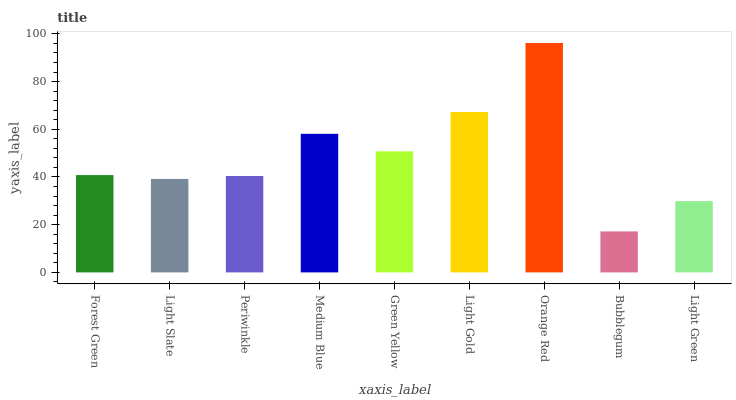Is Bubblegum the minimum?
Answer yes or no. Yes. Is Orange Red the maximum?
Answer yes or no. Yes. Is Light Slate the minimum?
Answer yes or no. No. Is Light Slate the maximum?
Answer yes or no. No. Is Forest Green greater than Light Slate?
Answer yes or no. Yes. Is Light Slate less than Forest Green?
Answer yes or no. Yes. Is Light Slate greater than Forest Green?
Answer yes or no. No. Is Forest Green less than Light Slate?
Answer yes or no. No. Is Forest Green the high median?
Answer yes or no. Yes. Is Forest Green the low median?
Answer yes or no. Yes. Is Light Green the high median?
Answer yes or no. No. Is Periwinkle the low median?
Answer yes or no. No. 